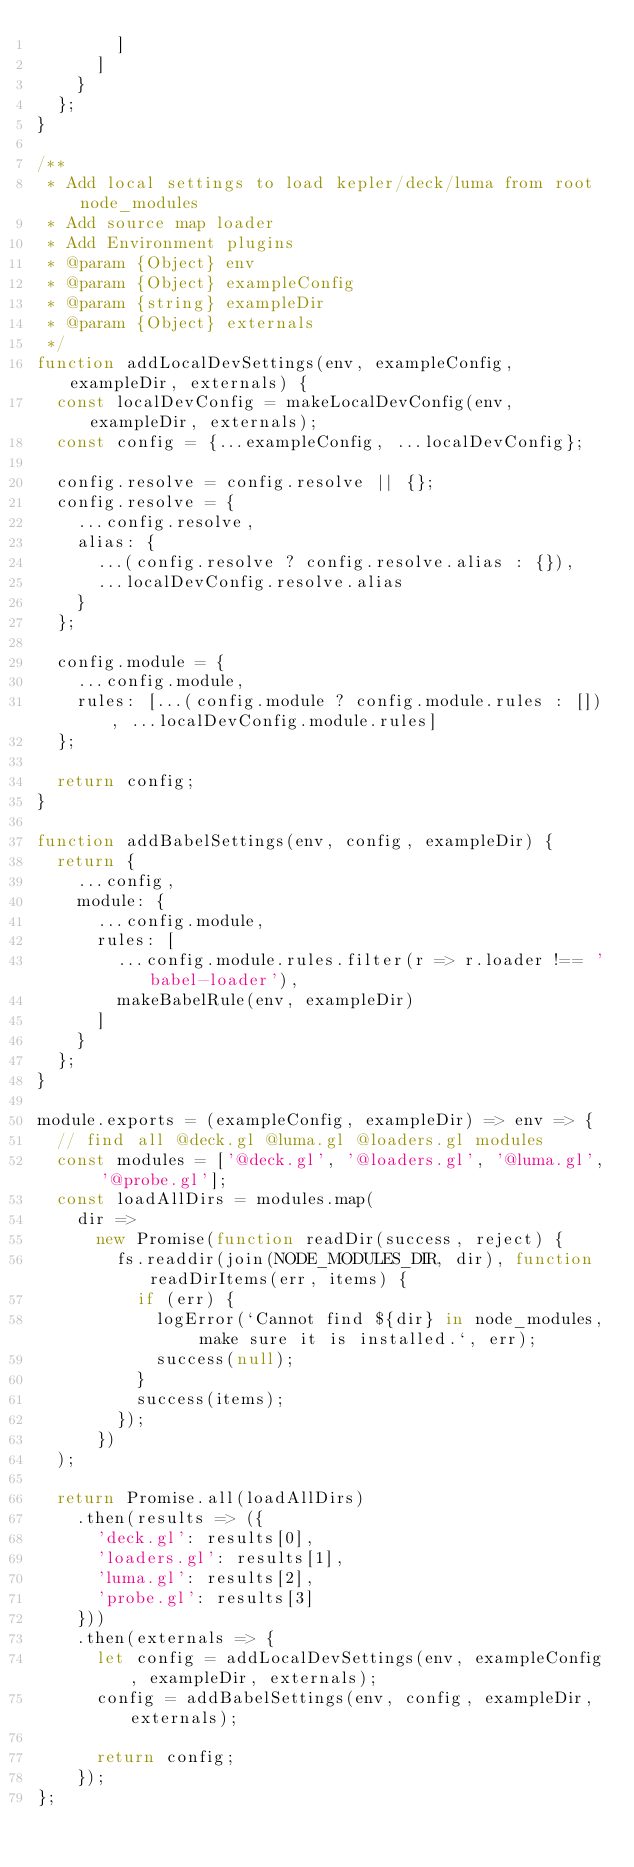<code> <loc_0><loc_0><loc_500><loc_500><_JavaScript_>        ]
      ]
    }
  };
}

/**
 * Add local settings to load kepler/deck/luma from root node_modules
 * Add source map loader
 * Add Environment plugins
 * @param {Object} env
 * @param {Object} exampleConfig
 * @param {string} exampleDir
 * @param {Object} externals
 */
function addLocalDevSettings(env, exampleConfig, exampleDir, externals) {
  const localDevConfig = makeLocalDevConfig(env, exampleDir, externals);
  const config = {...exampleConfig, ...localDevConfig};

  config.resolve = config.resolve || {};
  config.resolve = {
    ...config.resolve,
    alias: {
      ...(config.resolve ? config.resolve.alias : {}),
      ...localDevConfig.resolve.alias
    }
  };

  config.module = {
    ...config.module,
    rules: [...(config.module ? config.module.rules : []), ...localDevConfig.module.rules]
  };

  return config;
}

function addBabelSettings(env, config, exampleDir) {
  return {
    ...config,
    module: {
      ...config.module,
      rules: [
        ...config.module.rules.filter(r => r.loader !== 'babel-loader'),
        makeBabelRule(env, exampleDir)
      ]
    }
  };
}

module.exports = (exampleConfig, exampleDir) => env => {
  // find all @deck.gl @luma.gl @loaders.gl modules
  const modules = ['@deck.gl', '@loaders.gl', '@luma.gl', '@probe.gl'];
  const loadAllDirs = modules.map(
    dir =>
      new Promise(function readDir(success, reject) {
        fs.readdir(join(NODE_MODULES_DIR, dir), function readDirItems(err, items) {
          if (err) {
            logError(`Cannot find ${dir} in node_modules, make sure it is installed.`, err);
            success(null);
          }
          success(items);
        });
      })
  );

  return Promise.all(loadAllDirs)
    .then(results => ({
      'deck.gl': results[0],
      'loaders.gl': results[1],
      'luma.gl': results[2],
      'probe.gl': results[3]
    }))
    .then(externals => {
      let config = addLocalDevSettings(env, exampleConfig, exampleDir, externals);
      config = addBabelSettings(env, config, exampleDir, externals);

      return config;
    });
};
</code> 